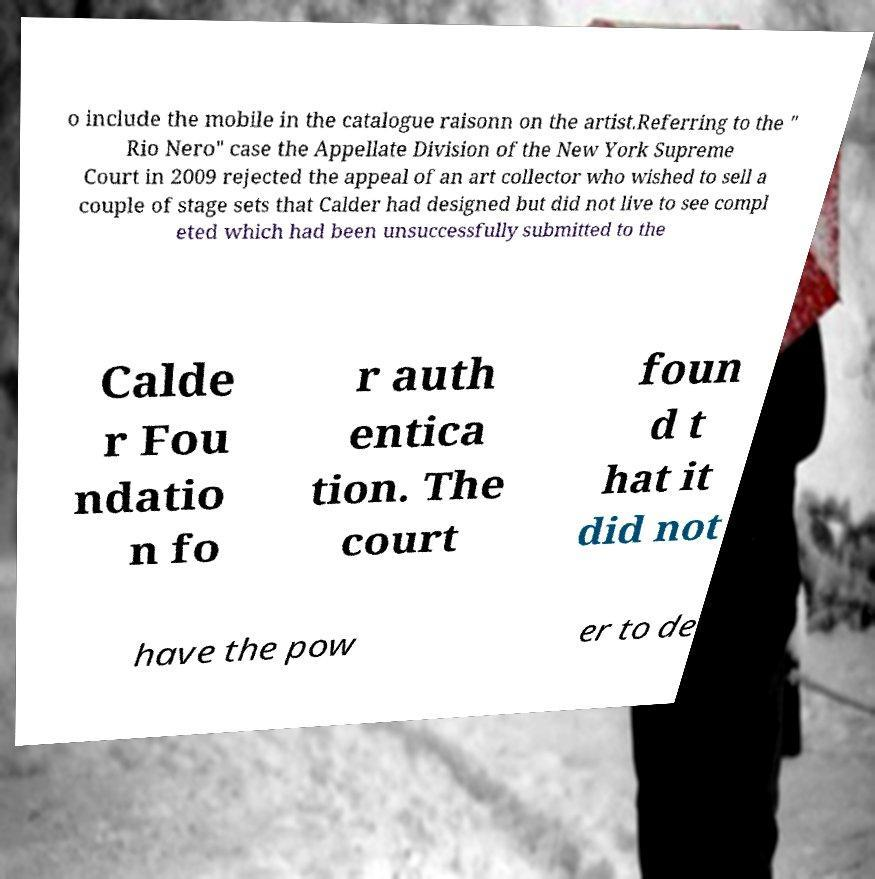Can you accurately transcribe the text from the provided image for me? o include the mobile in the catalogue raisonn on the artist.Referring to the " Rio Nero" case the Appellate Division of the New York Supreme Court in 2009 rejected the appeal of an art collector who wished to sell a couple of stage sets that Calder had designed but did not live to see compl eted which had been unsuccessfully submitted to the Calde r Fou ndatio n fo r auth entica tion. The court foun d t hat it did not have the pow er to de 